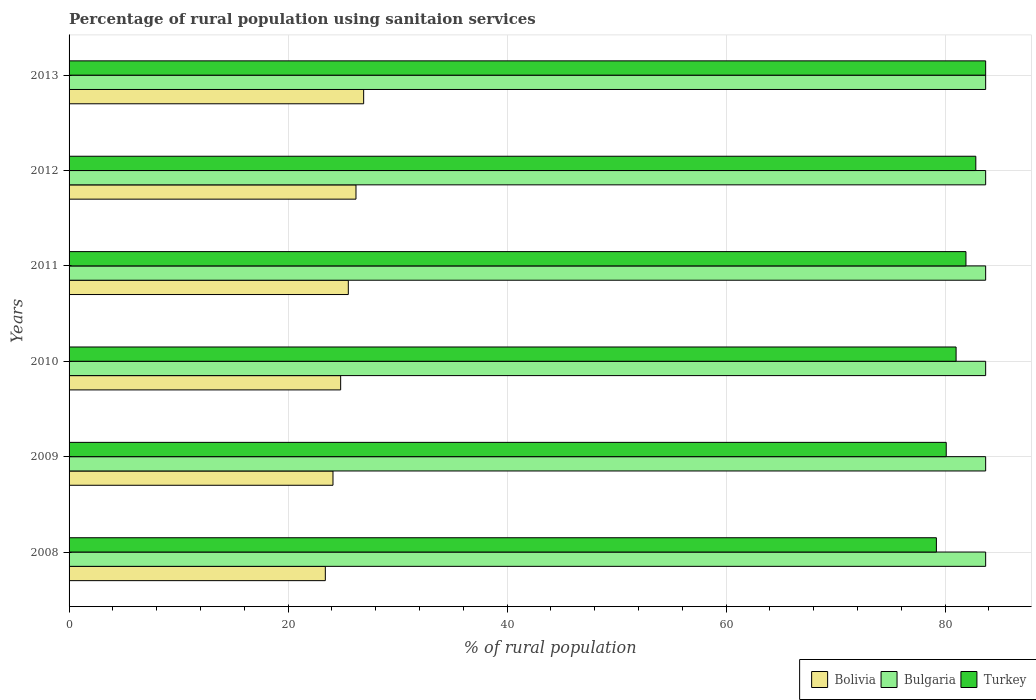How many different coloured bars are there?
Your answer should be very brief. 3. Are the number of bars per tick equal to the number of legend labels?
Provide a succinct answer. Yes. Are the number of bars on each tick of the Y-axis equal?
Your answer should be compact. Yes. What is the label of the 2nd group of bars from the top?
Offer a very short reply. 2012. What is the percentage of rural population using sanitaion services in Turkey in 2011?
Ensure brevity in your answer.  81.9. Across all years, what is the maximum percentage of rural population using sanitaion services in Turkey?
Offer a very short reply. 83.7. Across all years, what is the minimum percentage of rural population using sanitaion services in Turkey?
Your answer should be compact. 79.2. In which year was the percentage of rural population using sanitaion services in Turkey minimum?
Make the answer very short. 2008. What is the total percentage of rural population using sanitaion services in Bolivia in the graph?
Offer a very short reply. 150.9. What is the difference between the percentage of rural population using sanitaion services in Bolivia in 2009 and that in 2011?
Your answer should be compact. -1.4. What is the difference between the percentage of rural population using sanitaion services in Turkey in 2009 and the percentage of rural population using sanitaion services in Bulgaria in 2008?
Give a very brief answer. -3.6. What is the average percentage of rural population using sanitaion services in Turkey per year?
Provide a succinct answer. 81.45. In the year 2008, what is the difference between the percentage of rural population using sanitaion services in Bolivia and percentage of rural population using sanitaion services in Bulgaria?
Ensure brevity in your answer.  -60.3. In how many years, is the percentage of rural population using sanitaion services in Bulgaria greater than 12 %?
Your answer should be compact. 6. Is the percentage of rural population using sanitaion services in Bulgaria in 2012 less than that in 2013?
Your response must be concise. No. What is the difference between the highest and the second highest percentage of rural population using sanitaion services in Turkey?
Your answer should be compact. 0.9. What is the difference between the highest and the lowest percentage of rural population using sanitaion services in Bolivia?
Provide a succinct answer. 3.5. In how many years, is the percentage of rural population using sanitaion services in Turkey greater than the average percentage of rural population using sanitaion services in Turkey taken over all years?
Ensure brevity in your answer.  3. Is the sum of the percentage of rural population using sanitaion services in Bulgaria in 2008 and 2013 greater than the maximum percentage of rural population using sanitaion services in Turkey across all years?
Provide a succinct answer. Yes. What does the 3rd bar from the top in 2013 represents?
Give a very brief answer. Bolivia. What does the 2nd bar from the bottom in 2008 represents?
Give a very brief answer. Bulgaria. Are all the bars in the graph horizontal?
Make the answer very short. Yes. What is the difference between two consecutive major ticks on the X-axis?
Provide a succinct answer. 20. Does the graph contain grids?
Make the answer very short. Yes. Where does the legend appear in the graph?
Provide a succinct answer. Bottom right. How many legend labels are there?
Keep it short and to the point. 3. How are the legend labels stacked?
Your answer should be compact. Horizontal. What is the title of the graph?
Provide a succinct answer. Percentage of rural population using sanitaion services. What is the label or title of the X-axis?
Ensure brevity in your answer.  % of rural population. What is the % of rural population of Bolivia in 2008?
Ensure brevity in your answer.  23.4. What is the % of rural population of Bulgaria in 2008?
Offer a terse response. 83.7. What is the % of rural population in Turkey in 2008?
Give a very brief answer. 79.2. What is the % of rural population in Bolivia in 2009?
Your response must be concise. 24.1. What is the % of rural population in Bulgaria in 2009?
Ensure brevity in your answer.  83.7. What is the % of rural population of Turkey in 2009?
Provide a succinct answer. 80.1. What is the % of rural population in Bolivia in 2010?
Your response must be concise. 24.8. What is the % of rural population of Bulgaria in 2010?
Your answer should be very brief. 83.7. What is the % of rural population in Bolivia in 2011?
Offer a terse response. 25.5. What is the % of rural population in Bulgaria in 2011?
Offer a very short reply. 83.7. What is the % of rural population in Turkey in 2011?
Make the answer very short. 81.9. What is the % of rural population of Bolivia in 2012?
Your answer should be compact. 26.2. What is the % of rural population in Bulgaria in 2012?
Provide a short and direct response. 83.7. What is the % of rural population of Turkey in 2012?
Your response must be concise. 82.8. What is the % of rural population of Bolivia in 2013?
Give a very brief answer. 26.9. What is the % of rural population in Bulgaria in 2013?
Offer a very short reply. 83.7. What is the % of rural population in Turkey in 2013?
Ensure brevity in your answer.  83.7. Across all years, what is the maximum % of rural population in Bolivia?
Offer a terse response. 26.9. Across all years, what is the maximum % of rural population of Bulgaria?
Offer a very short reply. 83.7. Across all years, what is the maximum % of rural population in Turkey?
Offer a terse response. 83.7. Across all years, what is the minimum % of rural population in Bolivia?
Give a very brief answer. 23.4. Across all years, what is the minimum % of rural population of Bulgaria?
Your response must be concise. 83.7. Across all years, what is the minimum % of rural population in Turkey?
Offer a very short reply. 79.2. What is the total % of rural population of Bolivia in the graph?
Provide a succinct answer. 150.9. What is the total % of rural population of Bulgaria in the graph?
Your answer should be very brief. 502.2. What is the total % of rural population in Turkey in the graph?
Give a very brief answer. 488.7. What is the difference between the % of rural population in Bulgaria in 2008 and that in 2009?
Provide a short and direct response. 0. What is the difference between the % of rural population of Bulgaria in 2008 and that in 2010?
Your response must be concise. 0. What is the difference between the % of rural population in Bolivia in 2008 and that in 2011?
Your answer should be compact. -2.1. What is the difference between the % of rural population of Bulgaria in 2008 and that in 2011?
Provide a succinct answer. 0. What is the difference between the % of rural population in Bulgaria in 2008 and that in 2012?
Give a very brief answer. 0. What is the difference between the % of rural population of Bolivia in 2008 and that in 2013?
Your answer should be very brief. -3.5. What is the difference between the % of rural population of Turkey in 2009 and that in 2010?
Offer a terse response. -0.9. What is the difference between the % of rural population in Turkey in 2009 and that in 2011?
Your answer should be very brief. -1.8. What is the difference between the % of rural population in Bolivia in 2009 and that in 2012?
Keep it short and to the point. -2.1. What is the difference between the % of rural population in Turkey in 2009 and that in 2012?
Offer a very short reply. -2.7. What is the difference between the % of rural population of Bolivia in 2009 and that in 2013?
Give a very brief answer. -2.8. What is the difference between the % of rural population in Bulgaria in 2009 and that in 2013?
Make the answer very short. 0. What is the difference between the % of rural population in Turkey in 2009 and that in 2013?
Your response must be concise. -3.6. What is the difference between the % of rural population in Bulgaria in 2010 and that in 2011?
Give a very brief answer. 0. What is the difference between the % of rural population in Turkey in 2010 and that in 2011?
Provide a succinct answer. -0.9. What is the difference between the % of rural population of Bolivia in 2010 and that in 2012?
Make the answer very short. -1.4. What is the difference between the % of rural population in Turkey in 2010 and that in 2012?
Your response must be concise. -1.8. What is the difference between the % of rural population in Bulgaria in 2010 and that in 2013?
Offer a terse response. 0. What is the difference between the % of rural population of Turkey in 2010 and that in 2013?
Offer a terse response. -2.7. What is the difference between the % of rural population of Bolivia in 2011 and that in 2013?
Provide a short and direct response. -1.4. What is the difference between the % of rural population in Bulgaria in 2011 and that in 2013?
Keep it short and to the point. 0. What is the difference between the % of rural population of Bulgaria in 2012 and that in 2013?
Provide a succinct answer. 0. What is the difference between the % of rural population in Bolivia in 2008 and the % of rural population in Bulgaria in 2009?
Provide a succinct answer. -60.3. What is the difference between the % of rural population in Bolivia in 2008 and the % of rural population in Turkey in 2009?
Your response must be concise. -56.7. What is the difference between the % of rural population in Bolivia in 2008 and the % of rural population in Bulgaria in 2010?
Ensure brevity in your answer.  -60.3. What is the difference between the % of rural population of Bolivia in 2008 and the % of rural population of Turkey in 2010?
Make the answer very short. -57.6. What is the difference between the % of rural population of Bulgaria in 2008 and the % of rural population of Turkey in 2010?
Make the answer very short. 2.7. What is the difference between the % of rural population in Bolivia in 2008 and the % of rural population in Bulgaria in 2011?
Provide a short and direct response. -60.3. What is the difference between the % of rural population in Bolivia in 2008 and the % of rural population in Turkey in 2011?
Make the answer very short. -58.5. What is the difference between the % of rural population of Bulgaria in 2008 and the % of rural population of Turkey in 2011?
Ensure brevity in your answer.  1.8. What is the difference between the % of rural population in Bolivia in 2008 and the % of rural population in Bulgaria in 2012?
Your response must be concise. -60.3. What is the difference between the % of rural population of Bolivia in 2008 and the % of rural population of Turkey in 2012?
Provide a short and direct response. -59.4. What is the difference between the % of rural population of Bolivia in 2008 and the % of rural population of Bulgaria in 2013?
Give a very brief answer. -60.3. What is the difference between the % of rural population of Bolivia in 2008 and the % of rural population of Turkey in 2013?
Offer a very short reply. -60.3. What is the difference between the % of rural population of Bulgaria in 2008 and the % of rural population of Turkey in 2013?
Give a very brief answer. 0. What is the difference between the % of rural population of Bolivia in 2009 and the % of rural population of Bulgaria in 2010?
Keep it short and to the point. -59.6. What is the difference between the % of rural population of Bolivia in 2009 and the % of rural population of Turkey in 2010?
Ensure brevity in your answer.  -56.9. What is the difference between the % of rural population of Bolivia in 2009 and the % of rural population of Bulgaria in 2011?
Provide a short and direct response. -59.6. What is the difference between the % of rural population of Bolivia in 2009 and the % of rural population of Turkey in 2011?
Provide a succinct answer. -57.8. What is the difference between the % of rural population in Bolivia in 2009 and the % of rural population in Bulgaria in 2012?
Your answer should be very brief. -59.6. What is the difference between the % of rural population in Bolivia in 2009 and the % of rural population in Turkey in 2012?
Keep it short and to the point. -58.7. What is the difference between the % of rural population in Bulgaria in 2009 and the % of rural population in Turkey in 2012?
Ensure brevity in your answer.  0.9. What is the difference between the % of rural population of Bolivia in 2009 and the % of rural population of Bulgaria in 2013?
Offer a very short reply. -59.6. What is the difference between the % of rural population in Bolivia in 2009 and the % of rural population in Turkey in 2013?
Ensure brevity in your answer.  -59.6. What is the difference between the % of rural population in Bulgaria in 2009 and the % of rural population in Turkey in 2013?
Your response must be concise. 0. What is the difference between the % of rural population in Bolivia in 2010 and the % of rural population in Bulgaria in 2011?
Provide a succinct answer. -58.9. What is the difference between the % of rural population in Bolivia in 2010 and the % of rural population in Turkey in 2011?
Provide a short and direct response. -57.1. What is the difference between the % of rural population of Bulgaria in 2010 and the % of rural population of Turkey in 2011?
Keep it short and to the point. 1.8. What is the difference between the % of rural population in Bolivia in 2010 and the % of rural population in Bulgaria in 2012?
Provide a short and direct response. -58.9. What is the difference between the % of rural population in Bolivia in 2010 and the % of rural population in Turkey in 2012?
Your response must be concise. -58. What is the difference between the % of rural population in Bolivia in 2010 and the % of rural population in Bulgaria in 2013?
Give a very brief answer. -58.9. What is the difference between the % of rural population in Bolivia in 2010 and the % of rural population in Turkey in 2013?
Ensure brevity in your answer.  -58.9. What is the difference between the % of rural population in Bulgaria in 2010 and the % of rural population in Turkey in 2013?
Offer a very short reply. 0. What is the difference between the % of rural population in Bolivia in 2011 and the % of rural population in Bulgaria in 2012?
Offer a terse response. -58.2. What is the difference between the % of rural population of Bolivia in 2011 and the % of rural population of Turkey in 2012?
Make the answer very short. -57.3. What is the difference between the % of rural population in Bulgaria in 2011 and the % of rural population in Turkey in 2012?
Keep it short and to the point. 0.9. What is the difference between the % of rural population in Bolivia in 2011 and the % of rural population in Bulgaria in 2013?
Your answer should be very brief. -58.2. What is the difference between the % of rural population in Bolivia in 2011 and the % of rural population in Turkey in 2013?
Your response must be concise. -58.2. What is the difference between the % of rural population in Bolivia in 2012 and the % of rural population in Bulgaria in 2013?
Ensure brevity in your answer.  -57.5. What is the difference between the % of rural population in Bolivia in 2012 and the % of rural population in Turkey in 2013?
Offer a very short reply. -57.5. What is the difference between the % of rural population of Bulgaria in 2012 and the % of rural population of Turkey in 2013?
Your response must be concise. 0. What is the average % of rural population in Bolivia per year?
Keep it short and to the point. 25.15. What is the average % of rural population in Bulgaria per year?
Your response must be concise. 83.7. What is the average % of rural population of Turkey per year?
Give a very brief answer. 81.45. In the year 2008, what is the difference between the % of rural population of Bolivia and % of rural population of Bulgaria?
Provide a short and direct response. -60.3. In the year 2008, what is the difference between the % of rural population in Bolivia and % of rural population in Turkey?
Offer a very short reply. -55.8. In the year 2009, what is the difference between the % of rural population in Bolivia and % of rural population in Bulgaria?
Your answer should be very brief. -59.6. In the year 2009, what is the difference between the % of rural population in Bolivia and % of rural population in Turkey?
Offer a very short reply. -56. In the year 2010, what is the difference between the % of rural population of Bolivia and % of rural population of Bulgaria?
Give a very brief answer. -58.9. In the year 2010, what is the difference between the % of rural population in Bolivia and % of rural population in Turkey?
Offer a terse response. -56.2. In the year 2010, what is the difference between the % of rural population in Bulgaria and % of rural population in Turkey?
Your response must be concise. 2.7. In the year 2011, what is the difference between the % of rural population in Bolivia and % of rural population in Bulgaria?
Offer a very short reply. -58.2. In the year 2011, what is the difference between the % of rural population in Bolivia and % of rural population in Turkey?
Your response must be concise. -56.4. In the year 2011, what is the difference between the % of rural population of Bulgaria and % of rural population of Turkey?
Make the answer very short. 1.8. In the year 2012, what is the difference between the % of rural population in Bolivia and % of rural population in Bulgaria?
Offer a terse response. -57.5. In the year 2012, what is the difference between the % of rural population of Bolivia and % of rural population of Turkey?
Make the answer very short. -56.6. In the year 2013, what is the difference between the % of rural population of Bolivia and % of rural population of Bulgaria?
Your response must be concise. -56.8. In the year 2013, what is the difference between the % of rural population in Bolivia and % of rural population in Turkey?
Your response must be concise. -56.8. What is the ratio of the % of rural population in Bolivia in 2008 to that in 2009?
Your answer should be compact. 0.97. What is the ratio of the % of rural population of Bolivia in 2008 to that in 2010?
Ensure brevity in your answer.  0.94. What is the ratio of the % of rural population of Bulgaria in 2008 to that in 2010?
Your answer should be very brief. 1. What is the ratio of the % of rural population of Turkey in 2008 to that in 2010?
Make the answer very short. 0.98. What is the ratio of the % of rural population of Bolivia in 2008 to that in 2011?
Ensure brevity in your answer.  0.92. What is the ratio of the % of rural population in Bulgaria in 2008 to that in 2011?
Provide a succinct answer. 1. What is the ratio of the % of rural population in Bolivia in 2008 to that in 2012?
Offer a very short reply. 0.89. What is the ratio of the % of rural population of Bulgaria in 2008 to that in 2012?
Make the answer very short. 1. What is the ratio of the % of rural population of Turkey in 2008 to that in 2012?
Offer a very short reply. 0.96. What is the ratio of the % of rural population in Bolivia in 2008 to that in 2013?
Your response must be concise. 0.87. What is the ratio of the % of rural population in Bulgaria in 2008 to that in 2013?
Keep it short and to the point. 1. What is the ratio of the % of rural population of Turkey in 2008 to that in 2013?
Give a very brief answer. 0.95. What is the ratio of the % of rural population of Bolivia in 2009 to that in 2010?
Provide a short and direct response. 0.97. What is the ratio of the % of rural population of Bulgaria in 2009 to that in 2010?
Ensure brevity in your answer.  1. What is the ratio of the % of rural population of Turkey in 2009 to that in 2010?
Offer a very short reply. 0.99. What is the ratio of the % of rural population in Bolivia in 2009 to that in 2011?
Your response must be concise. 0.95. What is the ratio of the % of rural population in Bulgaria in 2009 to that in 2011?
Offer a very short reply. 1. What is the ratio of the % of rural population of Turkey in 2009 to that in 2011?
Provide a succinct answer. 0.98. What is the ratio of the % of rural population in Bolivia in 2009 to that in 2012?
Offer a very short reply. 0.92. What is the ratio of the % of rural population in Bulgaria in 2009 to that in 2012?
Offer a very short reply. 1. What is the ratio of the % of rural population in Turkey in 2009 to that in 2012?
Provide a succinct answer. 0.97. What is the ratio of the % of rural population of Bolivia in 2009 to that in 2013?
Provide a short and direct response. 0.9. What is the ratio of the % of rural population in Bulgaria in 2009 to that in 2013?
Offer a very short reply. 1. What is the ratio of the % of rural population in Turkey in 2009 to that in 2013?
Make the answer very short. 0.96. What is the ratio of the % of rural population of Bolivia in 2010 to that in 2011?
Give a very brief answer. 0.97. What is the ratio of the % of rural population of Bolivia in 2010 to that in 2012?
Your answer should be very brief. 0.95. What is the ratio of the % of rural population in Bulgaria in 2010 to that in 2012?
Provide a short and direct response. 1. What is the ratio of the % of rural population of Turkey in 2010 to that in 2012?
Give a very brief answer. 0.98. What is the ratio of the % of rural population in Bolivia in 2010 to that in 2013?
Provide a succinct answer. 0.92. What is the ratio of the % of rural population in Bulgaria in 2010 to that in 2013?
Offer a terse response. 1. What is the ratio of the % of rural population of Bolivia in 2011 to that in 2012?
Provide a short and direct response. 0.97. What is the ratio of the % of rural population of Bulgaria in 2011 to that in 2012?
Offer a terse response. 1. What is the ratio of the % of rural population in Turkey in 2011 to that in 2012?
Offer a terse response. 0.99. What is the ratio of the % of rural population of Bolivia in 2011 to that in 2013?
Your answer should be very brief. 0.95. What is the ratio of the % of rural population in Turkey in 2011 to that in 2013?
Make the answer very short. 0.98. What is the ratio of the % of rural population of Bolivia in 2012 to that in 2013?
Ensure brevity in your answer.  0.97. What is the ratio of the % of rural population of Turkey in 2012 to that in 2013?
Offer a terse response. 0.99. What is the difference between the highest and the second highest % of rural population of Bulgaria?
Give a very brief answer. 0. What is the difference between the highest and the second highest % of rural population in Turkey?
Provide a succinct answer. 0.9. 